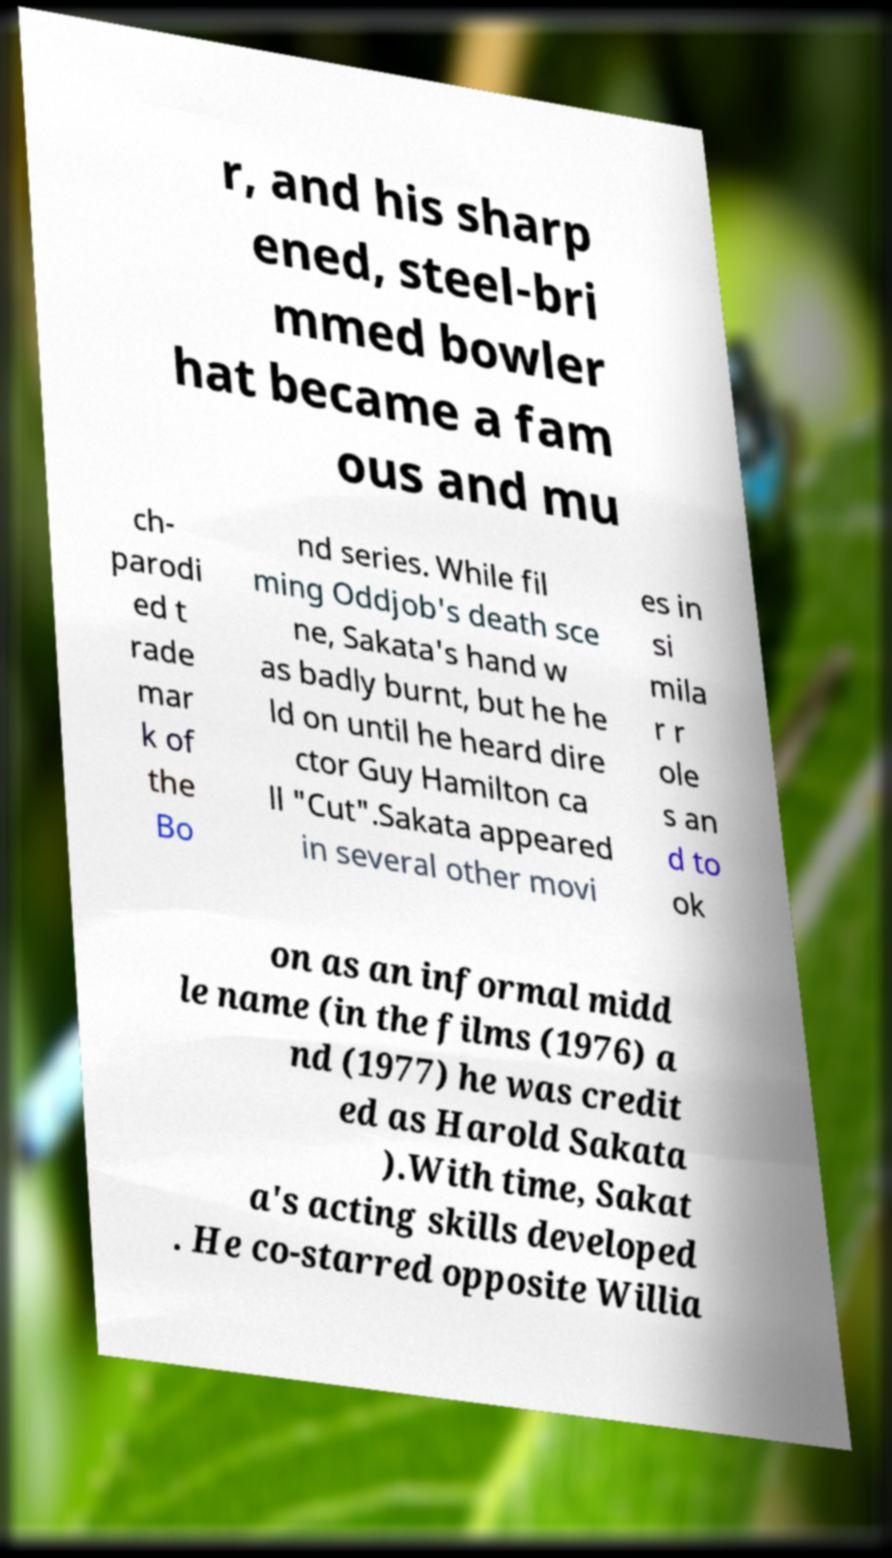Can you accurately transcribe the text from the provided image for me? r, and his sharp ened, steel-bri mmed bowler hat became a fam ous and mu ch- parodi ed t rade mar k of the Bo nd series. While fil ming Oddjob's death sce ne, Sakata's hand w as badly burnt, but he he ld on until he heard dire ctor Guy Hamilton ca ll "Cut".Sakata appeared in several other movi es in si mila r r ole s an d to ok on as an informal midd le name (in the films (1976) a nd (1977) he was credit ed as Harold Sakata ).With time, Sakat a's acting skills developed . He co-starred opposite Willia 